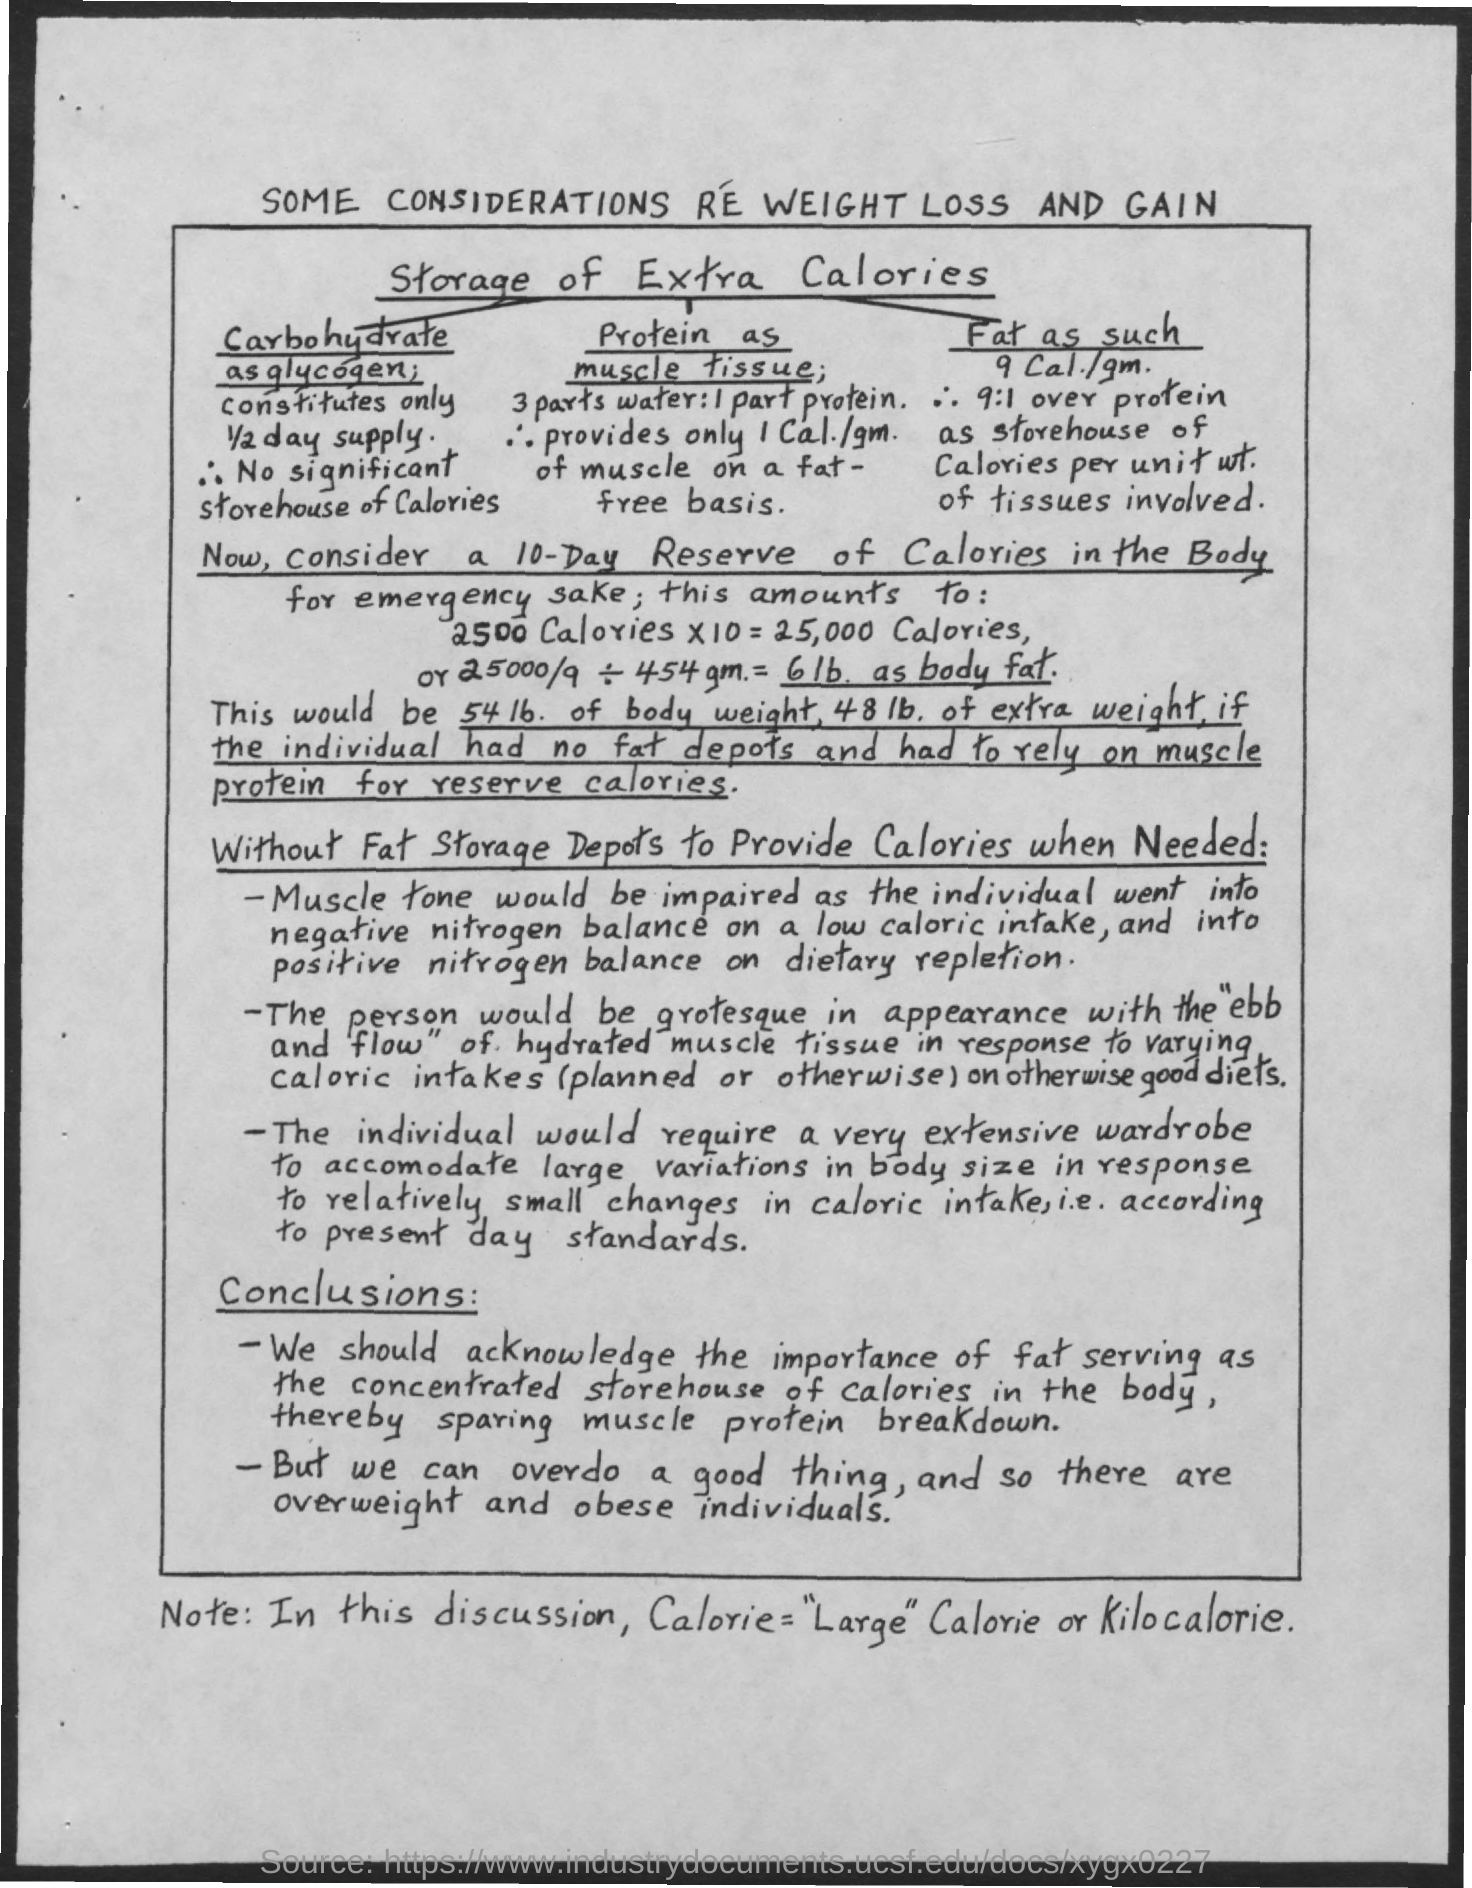What is the document about?
Your answer should be compact. Some considerations re weight loss and gain. What does large calorie mean?
Provide a succinct answer. Kilocalorie. 